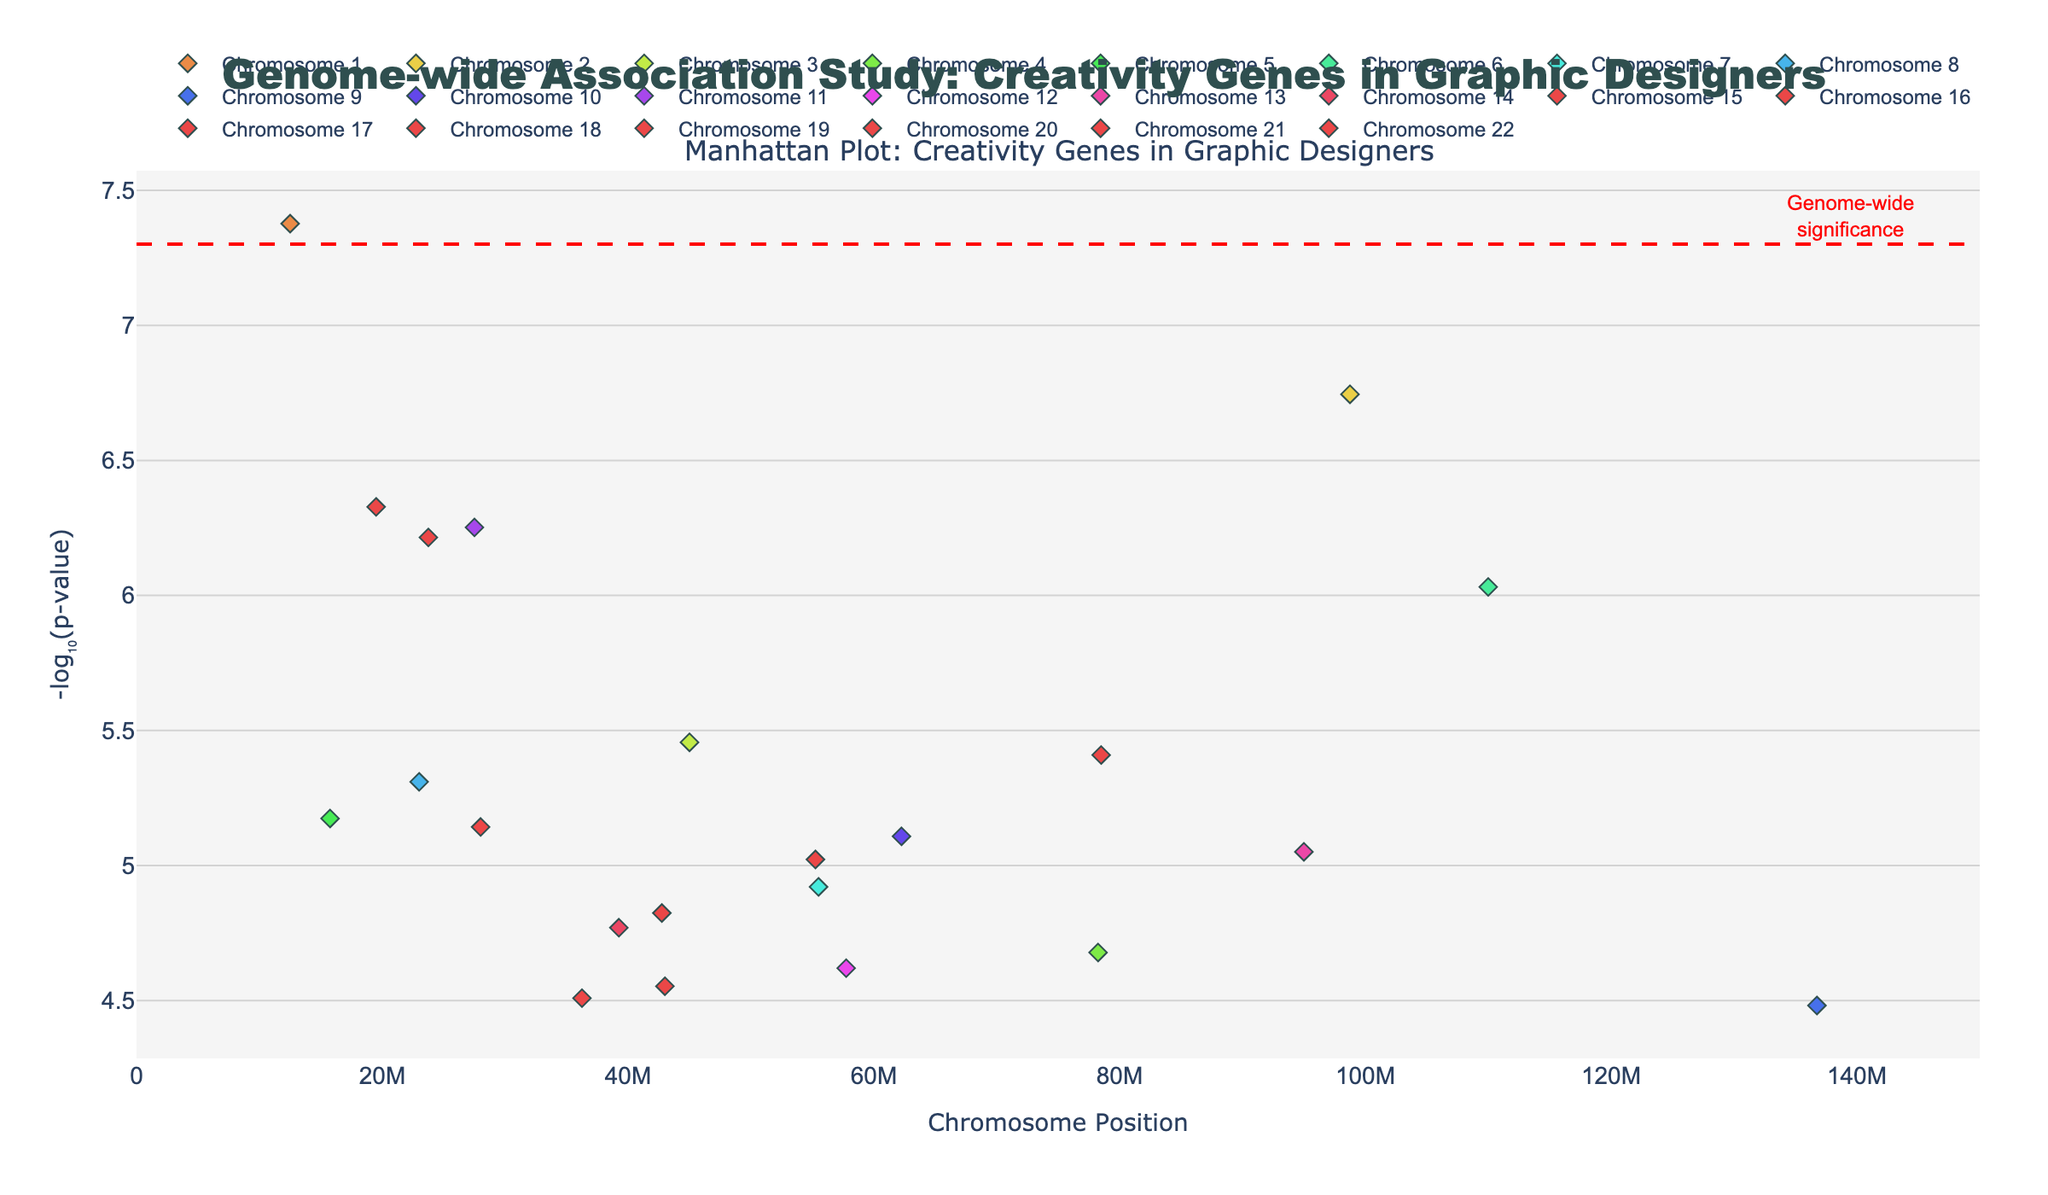What's the title of the plot? The title of the plot is located at the top and directly stated.
Answer: Genome-wide Association Study: Creativity Genes in Graphic Designers Which chromosome has a gene with the smallest p-value? Look at the y-axis; the smallest p-value corresponds to the highest -log10(p-value). Chromosome 1 has the highest point indicating the gene FOXP2.
Answer: Chromosome 1 How many genes have a -log10(p-value) greater than 6? Identify all points above the y-axis value of 6 and count them. Given this, it can be noted that there are several data points that surpass this threshold.
Answer: 6 Which gene is represented at the highest point on the plot? The highest y-value on the plot indicates the smallest p-value. The gene FOXP2 on Chromosome 1 is located at the highest point.
Answer: FOXP2 What's the significance threshold line represented in the plot? The horizontal red dashed line represents the genome-wide significance threshold, usually at -log10(5e-8).
Answer: -log10(5e-8) Are there any genes located on Chromosome 11 shown in the plot? Yes, check for any scatter points labeled with Chromosome 11, and the gene names such as BDNF-AS located at position 27500000.
Answer: Yes Which two genes on different chromosomes have the closest positions to each other? Compare the position values of genes on different chromosomes to see which two are closest. The genes nearest in position are SLC6A3 on Chromosome 5 at 15,750,000 and CREBBP on Chromosome 16 at 23,750,000.
Answer: SLC6A3 and CREBBP What's the gene with the p-value closest to the threshold for genome-wide significance? Identify the point closest to the red dashed line, which represents the significance threshold at -log10(5e-8). BDNF-AS on Chromosome 11 with a -log10(p-value) of approximately 6.25 is closest.
Answer: BDNF-AS Which chromosome has the most significant genes (based on their -log10(p-value) being higher than 5)? Observe the plot and count how many significant genes each chromosome has. The chromosome with the most significant genes is Chromosome 1 which has the gene FOXP2.
Answer: Chromosome 1 What can be concluded about the genes on Chromosome 6? Examine Chromosome 6's points on the plot, located at position 110000000 with the gene SNAP25 showing a notable significant -log10(p-value) higher than 6. This indicates the gene SNAP25 is very significant on Chromosome 6.
Answer: Gene SNAP25 is significant on Chromosome 6 